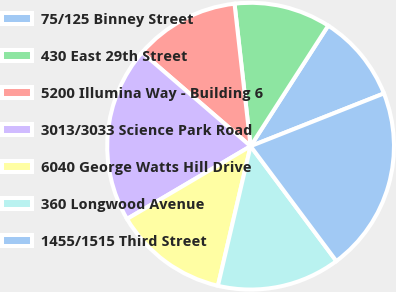<chart> <loc_0><loc_0><loc_500><loc_500><pie_chart><fcel>75/125 Binney Street<fcel>430 East 29th Street<fcel>5200 Illumina Way - Building 6<fcel>3013/3033 Science Park Road<fcel>6040 George Watts Hill Drive<fcel>360 Longwood Avenue<fcel>1455/1515 Third Street<nl><fcel>9.9%<fcel>10.89%<fcel>11.88%<fcel>19.8%<fcel>12.87%<fcel>13.86%<fcel>20.79%<nl></chart> 